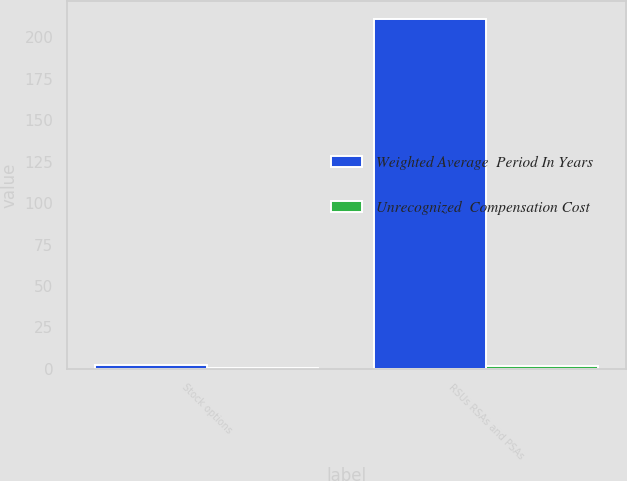Convert chart to OTSL. <chart><loc_0><loc_0><loc_500><loc_500><stacked_bar_chart><ecel><fcel>Stock options<fcel>RSUs RSAs and PSAs<nl><fcel>Weighted Average  Period In Years<fcel>2.1<fcel>211.2<nl><fcel>Unrecognized  Compensation Cost<fcel>0.6<fcel>1.7<nl></chart> 